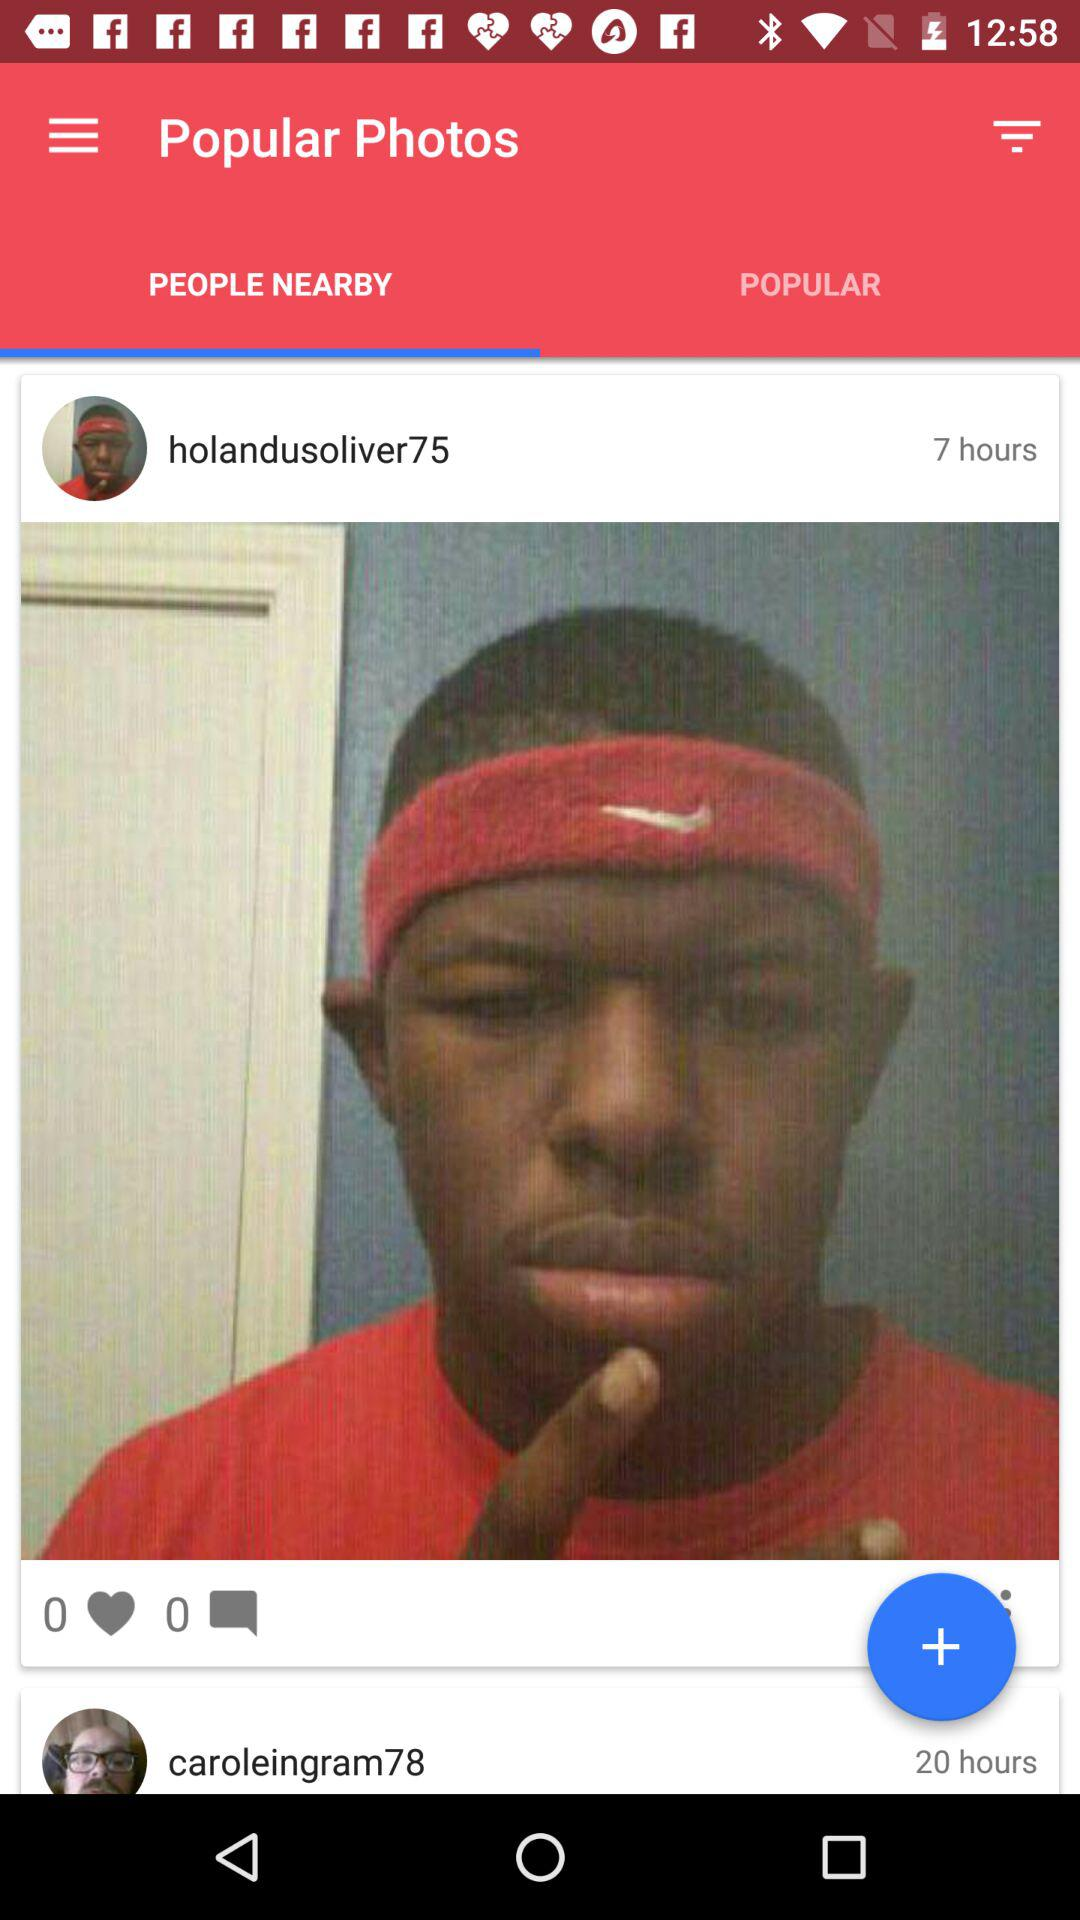Which photos are saved in the "POPULAR" tab?
When the provided information is insufficient, respond with <no answer>. <no answer> 